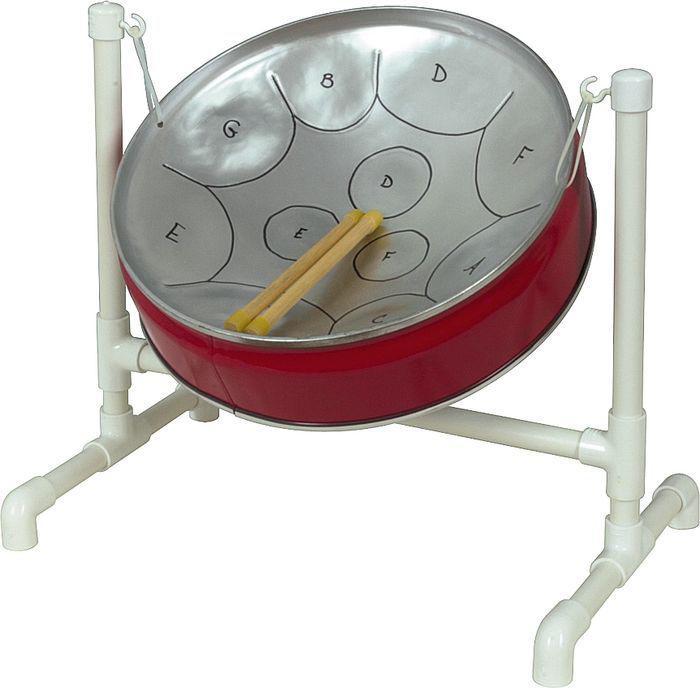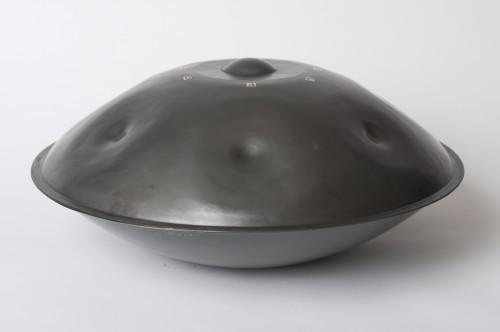The first image is the image on the left, the second image is the image on the right. Assess this claim about the two images: "The right image contains a single chrome metal drum with two drum sticks resting on top of the drum.". Correct or not? Answer yes or no. No. The first image is the image on the left, the second image is the image on the right. Assess this claim about the two images: "The designs of two steel drums are different, as are their stands, but each has two sticks resting in the drum.". Correct or not? Answer yes or no. No. 